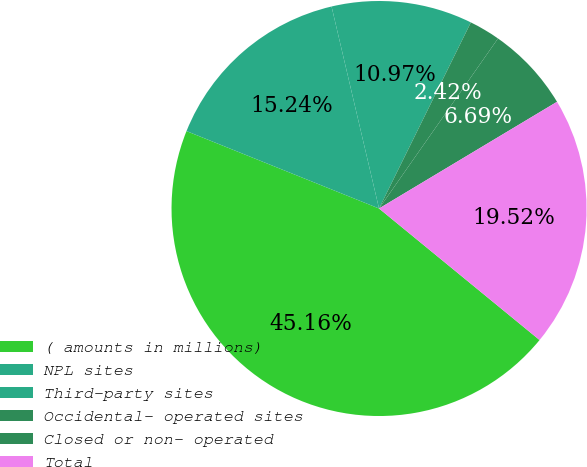<chart> <loc_0><loc_0><loc_500><loc_500><pie_chart><fcel>( amounts in millions)<fcel>NPL sites<fcel>Third-party sites<fcel>Occidental- operated sites<fcel>Closed or non- operated<fcel>Total<nl><fcel>45.16%<fcel>15.24%<fcel>10.97%<fcel>2.42%<fcel>6.69%<fcel>19.52%<nl></chart> 